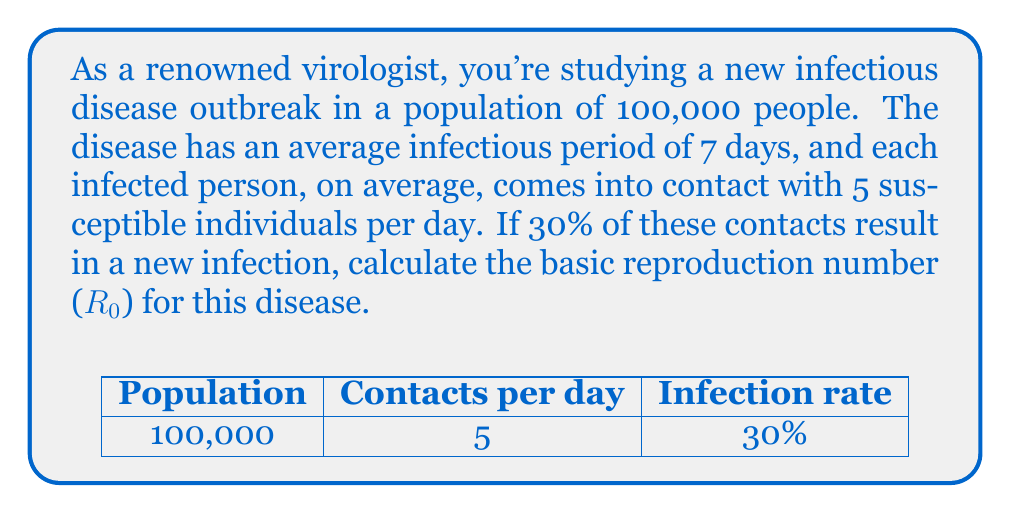Show me your answer to this math problem. To calculate the basic reproduction number (R0), we need to follow these steps:

1. Identify the key components:
   - Average infectious period (D) = 7 days
   - Average number of contacts per day (C) = 5
   - Probability of infection per contact (P) = 30% = 0.3

2. Apply the formula for R0:
   $$R0 = C \times P \times D$$

   Where:
   - C is the average number of contacts per day
   - P is the probability of infection per contact
   - D is the duration of infectiousness in days

3. Substitute the values:
   $$R0 = 5 \times 0.3 \times 7$$

4. Calculate:
   $$R0 = 1.5 \times 7 = 10.5$$

The basic reproduction number (R0) represents the average number of secondary infections caused by one infected individual in a completely susceptible population. In this case, R0 > 1, indicating that the disease has the potential to cause an epidemic.
Answer: $R0 = 10.5$ 